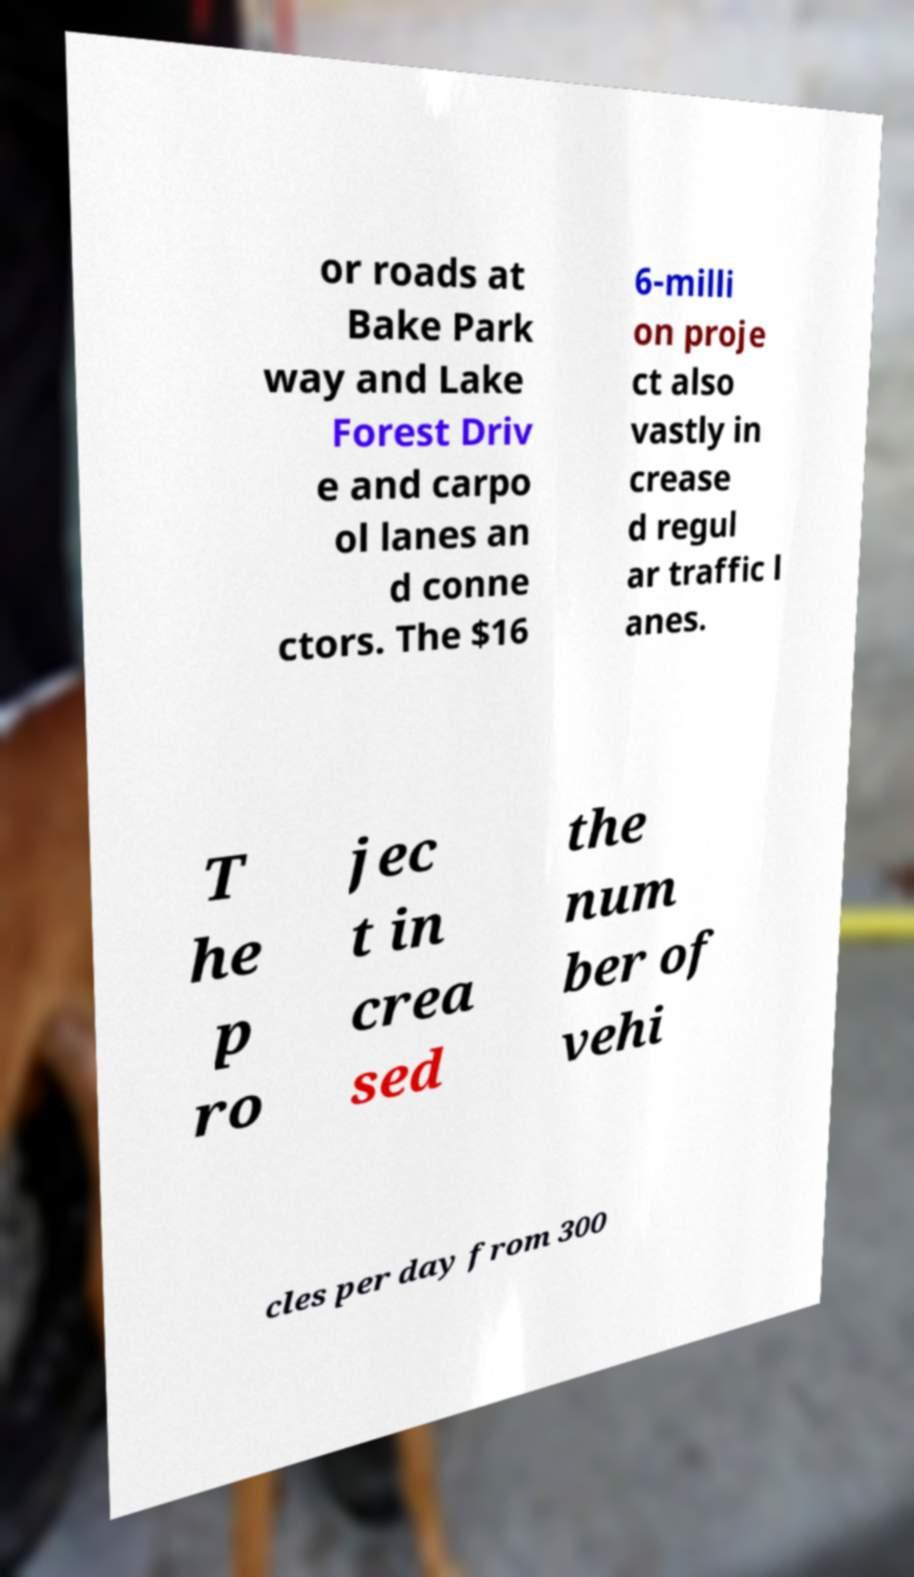Can you accurately transcribe the text from the provided image for me? or roads at Bake Park way and Lake Forest Driv e and carpo ol lanes an d conne ctors. The $16 6-milli on proje ct also vastly in crease d regul ar traffic l anes. T he p ro jec t in crea sed the num ber of vehi cles per day from 300 